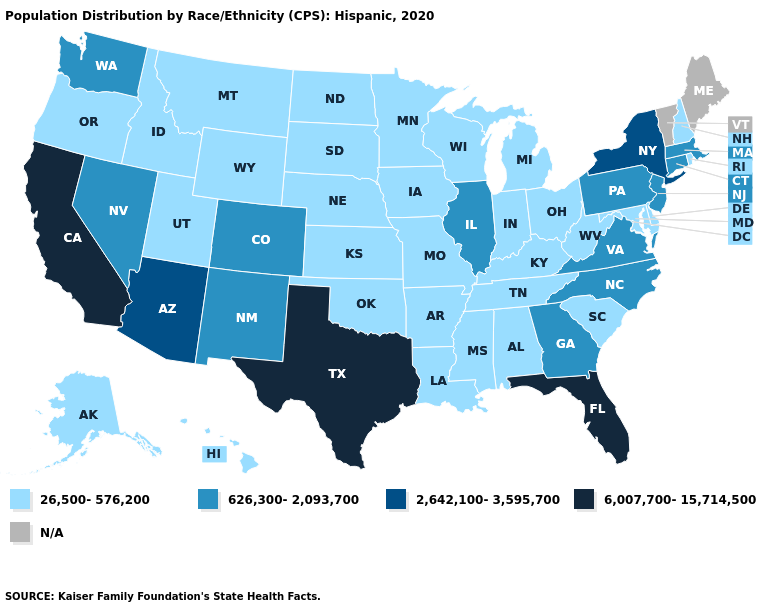What is the value of Arizona?
Give a very brief answer. 2,642,100-3,595,700. What is the lowest value in states that border Alabama?
Be succinct. 26,500-576,200. Does Georgia have the lowest value in the South?
Short answer required. No. Name the states that have a value in the range 626,300-2,093,700?
Be succinct. Colorado, Connecticut, Georgia, Illinois, Massachusetts, Nevada, New Jersey, New Mexico, North Carolina, Pennsylvania, Virginia, Washington. What is the value of Oregon?
Give a very brief answer. 26,500-576,200. Among the states that border Arizona , does California have the highest value?
Quick response, please. Yes. Name the states that have a value in the range 6,007,700-15,714,500?
Quick response, please. California, Florida, Texas. What is the lowest value in states that border Iowa?
Short answer required. 26,500-576,200. What is the value of Alaska?
Short answer required. 26,500-576,200. What is the highest value in the USA?
Quick response, please. 6,007,700-15,714,500. What is the value of Mississippi?
Answer briefly. 26,500-576,200. What is the value of California?
Write a very short answer. 6,007,700-15,714,500. How many symbols are there in the legend?
Quick response, please. 5. Name the states that have a value in the range 626,300-2,093,700?
Give a very brief answer. Colorado, Connecticut, Georgia, Illinois, Massachusetts, Nevada, New Jersey, New Mexico, North Carolina, Pennsylvania, Virginia, Washington. 